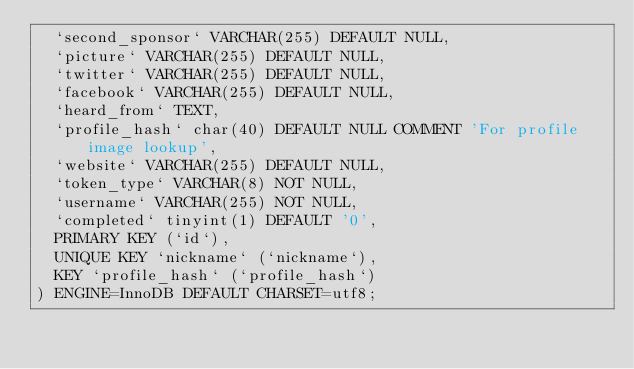Convert code to text. <code><loc_0><loc_0><loc_500><loc_500><_SQL_>  `second_sponsor` VARCHAR(255) DEFAULT NULL,
  `picture` VARCHAR(255) DEFAULT NULL,
  `twitter` VARCHAR(255) DEFAULT NULL,
  `facebook` VARCHAR(255) DEFAULT NULL,
  `heard_from` TEXT,
  `profile_hash` char(40) DEFAULT NULL COMMENT 'For profile image lookup',
  `website` VARCHAR(255) DEFAULT NULL,
  `token_type` VARCHAR(8) NOT NULL,
  `username` VARCHAR(255) NOT NULL,
  `completed` tinyint(1) DEFAULT '0',
  PRIMARY KEY (`id`),
  UNIQUE KEY `nickname` (`nickname`),
  KEY `profile_hash` (`profile_hash`)
) ENGINE=InnoDB DEFAULT CHARSET=utf8;
</code> 